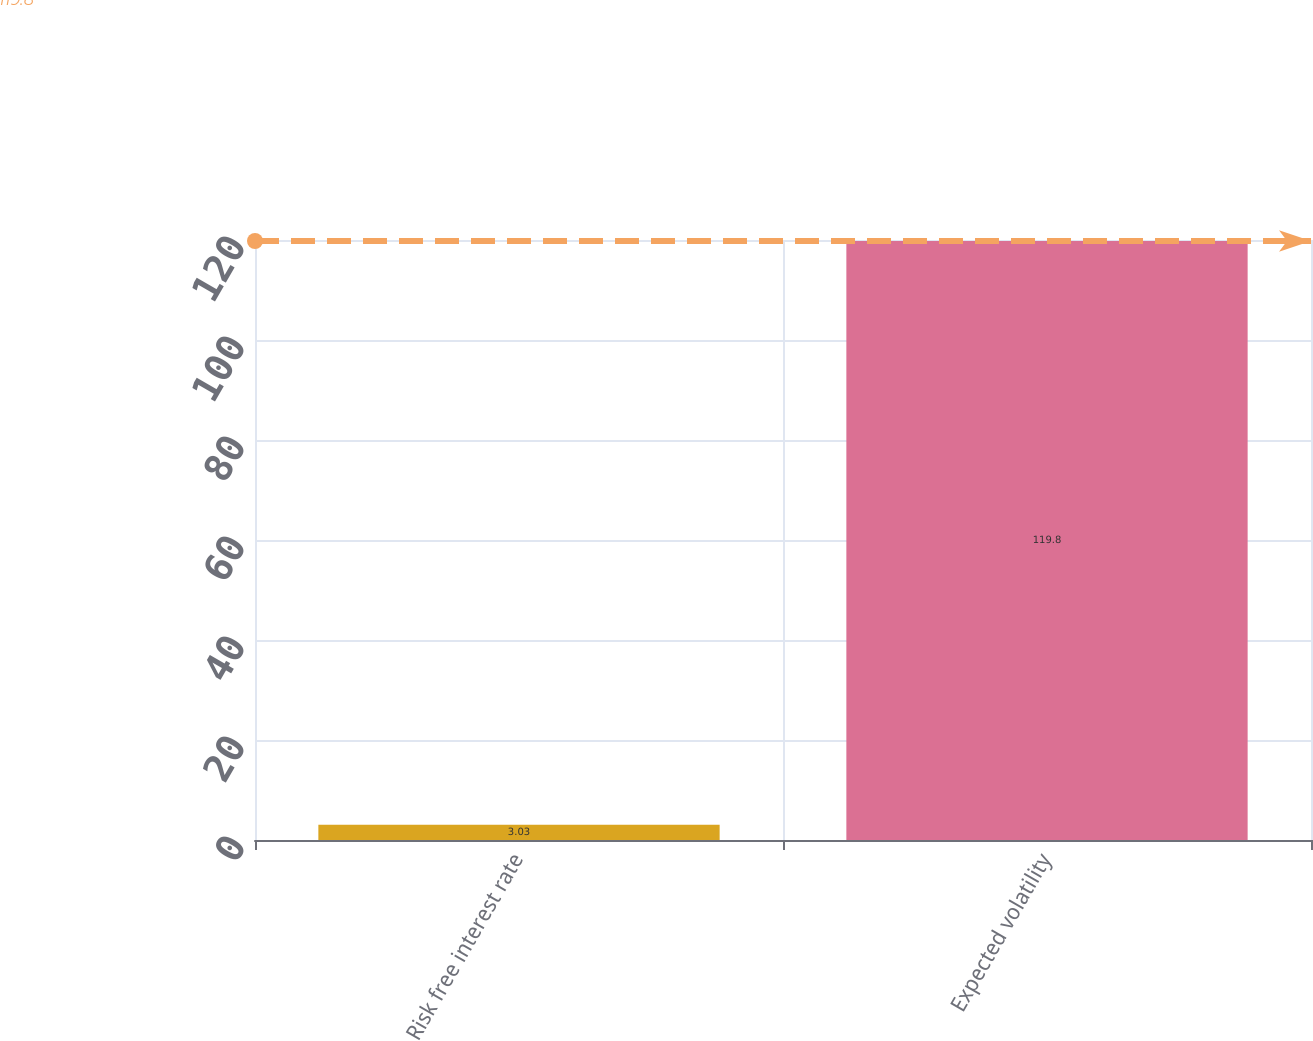<chart> <loc_0><loc_0><loc_500><loc_500><bar_chart><fcel>Risk free interest rate<fcel>Expected volatility<nl><fcel>3.03<fcel>119.8<nl></chart> 